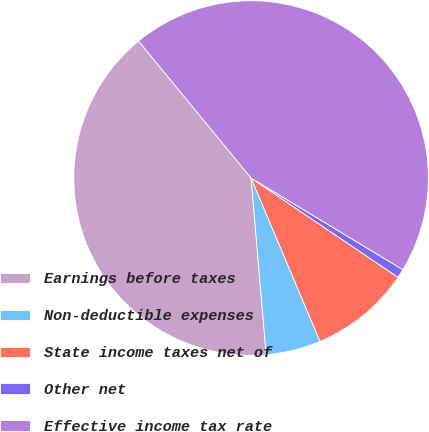<chart> <loc_0><loc_0><loc_500><loc_500><pie_chart><fcel>Earnings before taxes<fcel>Non-deductible expenses<fcel>State income taxes net of<fcel>Other net<fcel>Effective income tax rate<nl><fcel>40.41%<fcel>5.0%<fcel>9.19%<fcel>0.81%<fcel>44.6%<nl></chart> 